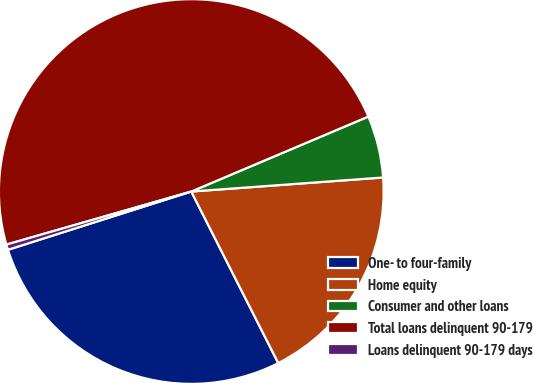Convert chart. <chart><loc_0><loc_0><loc_500><loc_500><pie_chart><fcel>One- to four-family<fcel>Home equity<fcel>Consumer and other loans<fcel>Total loans delinquent 90-179<fcel>Loans delinquent 90-179 days<nl><fcel>27.57%<fcel>18.69%<fcel>5.21%<fcel>48.07%<fcel>0.45%<nl></chart> 